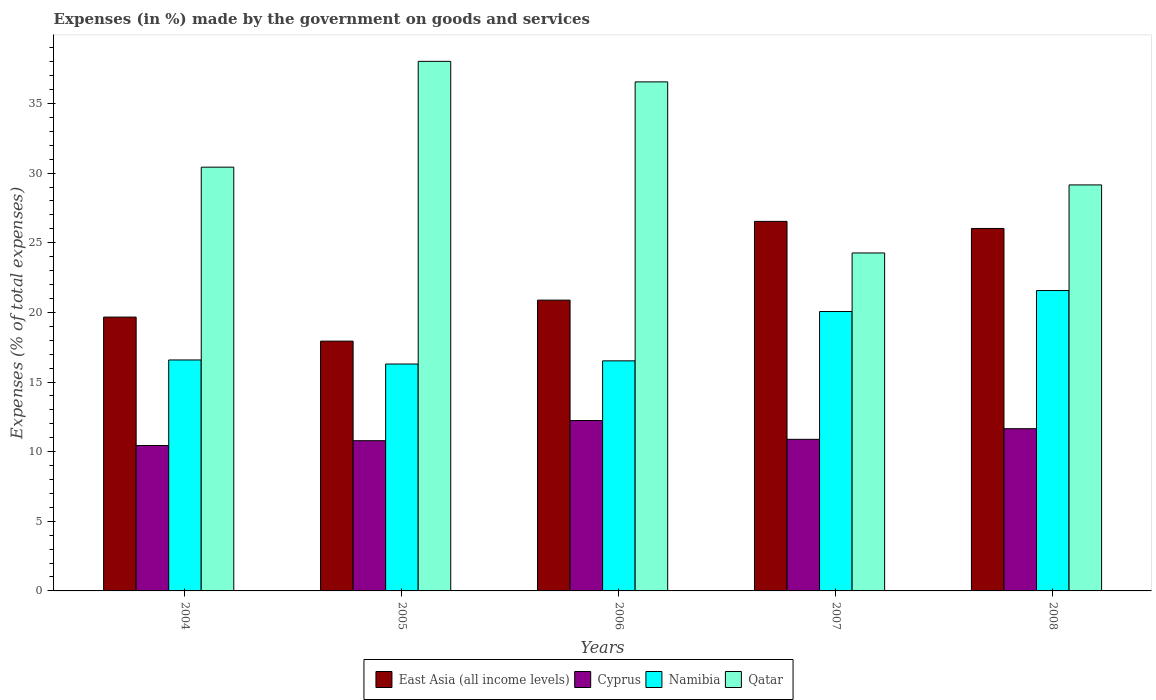Are the number of bars per tick equal to the number of legend labels?
Your answer should be compact. Yes. How many bars are there on the 2nd tick from the right?
Your answer should be very brief. 4. What is the label of the 5th group of bars from the left?
Keep it short and to the point. 2008. What is the percentage of expenses made by the government on goods and services in Qatar in 2007?
Make the answer very short. 24.27. Across all years, what is the maximum percentage of expenses made by the government on goods and services in East Asia (all income levels)?
Your answer should be compact. 26.53. Across all years, what is the minimum percentage of expenses made by the government on goods and services in Qatar?
Provide a short and direct response. 24.27. In which year was the percentage of expenses made by the government on goods and services in East Asia (all income levels) minimum?
Your answer should be compact. 2005. What is the total percentage of expenses made by the government on goods and services in Cyprus in the graph?
Ensure brevity in your answer.  56. What is the difference between the percentage of expenses made by the government on goods and services in Namibia in 2005 and that in 2006?
Provide a succinct answer. -0.23. What is the difference between the percentage of expenses made by the government on goods and services in Cyprus in 2007 and the percentage of expenses made by the government on goods and services in East Asia (all income levels) in 2004?
Make the answer very short. -8.78. What is the average percentage of expenses made by the government on goods and services in East Asia (all income levels) per year?
Provide a short and direct response. 22.21. In the year 2007, what is the difference between the percentage of expenses made by the government on goods and services in East Asia (all income levels) and percentage of expenses made by the government on goods and services in Qatar?
Make the answer very short. 2.27. In how many years, is the percentage of expenses made by the government on goods and services in Namibia greater than 13 %?
Your answer should be very brief. 5. What is the ratio of the percentage of expenses made by the government on goods and services in Qatar in 2005 to that in 2006?
Provide a succinct answer. 1.04. Is the percentage of expenses made by the government on goods and services in East Asia (all income levels) in 2004 less than that in 2006?
Provide a succinct answer. Yes. What is the difference between the highest and the second highest percentage of expenses made by the government on goods and services in Cyprus?
Your answer should be compact. 0.59. What is the difference between the highest and the lowest percentage of expenses made by the government on goods and services in Qatar?
Make the answer very short. 13.76. In how many years, is the percentage of expenses made by the government on goods and services in Qatar greater than the average percentage of expenses made by the government on goods and services in Qatar taken over all years?
Provide a short and direct response. 2. Is the sum of the percentage of expenses made by the government on goods and services in Namibia in 2004 and 2007 greater than the maximum percentage of expenses made by the government on goods and services in East Asia (all income levels) across all years?
Your response must be concise. Yes. Is it the case that in every year, the sum of the percentage of expenses made by the government on goods and services in East Asia (all income levels) and percentage of expenses made by the government on goods and services in Namibia is greater than the sum of percentage of expenses made by the government on goods and services in Cyprus and percentage of expenses made by the government on goods and services in Qatar?
Give a very brief answer. No. What does the 3rd bar from the left in 2004 represents?
Keep it short and to the point. Namibia. What does the 3rd bar from the right in 2006 represents?
Ensure brevity in your answer.  Cyprus. Is it the case that in every year, the sum of the percentage of expenses made by the government on goods and services in East Asia (all income levels) and percentage of expenses made by the government on goods and services in Cyprus is greater than the percentage of expenses made by the government on goods and services in Namibia?
Your response must be concise. Yes. How many bars are there?
Offer a terse response. 20. Are all the bars in the graph horizontal?
Your answer should be compact. No. What is the difference between two consecutive major ticks on the Y-axis?
Make the answer very short. 5. Where does the legend appear in the graph?
Give a very brief answer. Bottom center. How are the legend labels stacked?
Your answer should be compact. Horizontal. What is the title of the graph?
Provide a succinct answer. Expenses (in %) made by the government on goods and services. Does "Philippines" appear as one of the legend labels in the graph?
Ensure brevity in your answer.  No. What is the label or title of the Y-axis?
Provide a short and direct response. Expenses (% of total expenses). What is the Expenses (% of total expenses) of East Asia (all income levels) in 2004?
Provide a succinct answer. 19.66. What is the Expenses (% of total expenses) of Cyprus in 2004?
Keep it short and to the point. 10.44. What is the Expenses (% of total expenses) in Namibia in 2004?
Ensure brevity in your answer.  16.58. What is the Expenses (% of total expenses) of Qatar in 2004?
Offer a very short reply. 30.43. What is the Expenses (% of total expenses) of East Asia (all income levels) in 2005?
Offer a very short reply. 17.94. What is the Expenses (% of total expenses) of Cyprus in 2005?
Your answer should be compact. 10.79. What is the Expenses (% of total expenses) in Namibia in 2005?
Your response must be concise. 16.29. What is the Expenses (% of total expenses) in Qatar in 2005?
Offer a terse response. 38.02. What is the Expenses (% of total expenses) of East Asia (all income levels) in 2006?
Your answer should be very brief. 20.88. What is the Expenses (% of total expenses) of Cyprus in 2006?
Make the answer very short. 12.24. What is the Expenses (% of total expenses) in Namibia in 2006?
Give a very brief answer. 16.52. What is the Expenses (% of total expenses) in Qatar in 2006?
Provide a succinct answer. 36.55. What is the Expenses (% of total expenses) of East Asia (all income levels) in 2007?
Provide a short and direct response. 26.53. What is the Expenses (% of total expenses) in Cyprus in 2007?
Give a very brief answer. 10.89. What is the Expenses (% of total expenses) of Namibia in 2007?
Your answer should be very brief. 20.06. What is the Expenses (% of total expenses) in Qatar in 2007?
Your answer should be very brief. 24.27. What is the Expenses (% of total expenses) in East Asia (all income levels) in 2008?
Your response must be concise. 26.02. What is the Expenses (% of total expenses) in Cyprus in 2008?
Give a very brief answer. 11.65. What is the Expenses (% of total expenses) of Namibia in 2008?
Offer a terse response. 21.57. What is the Expenses (% of total expenses) in Qatar in 2008?
Ensure brevity in your answer.  29.15. Across all years, what is the maximum Expenses (% of total expenses) of East Asia (all income levels)?
Ensure brevity in your answer.  26.53. Across all years, what is the maximum Expenses (% of total expenses) of Cyprus?
Provide a short and direct response. 12.24. Across all years, what is the maximum Expenses (% of total expenses) of Namibia?
Your response must be concise. 21.57. Across all years, what is the maximum Expenses (% of total expenses) in Qatar?
Your answer should be compact. 38.02. Across all years, what is the minimum Expenses (% of total expenses) of East Asia (all income levels)?
Provide a succinct answer. 17.94. Across all years, what is the minimum Expenses (% of total expenses) in Cyprus?
Provide a succinct answer. 10.44. Across all years, what is the minimum Expenses (% of total expenses) in Namibia?
Give a very brief answer. 16.29. Across all years, what is the minimum Expenses (% of total expenses) of Qatar?
Offer a terse response. 24.27. What is the total Expenses (% of total expenses) of East Asia (all income levels) in the graph?
Your answer should be compact. 111.03. What is the total Expenses (% of total expenses) in Cyprus in the graph?
Offer a very short reply. 56. What is the total Expenses (% of total expenses) of Namibia in the graph?
Offer a terse response. 91.02. What is the total Expenses (% of total expenses) of Qatar in the graph?
Provide a succinct answer. 158.42. What is the difference between the Expenses (% of total expenses) in East Asia (all income levels) in 2004 and that in 2005?
Your answer should be compact. 1.73. What is the difference between the Expenses (% of total expenses) of Cyprus in 2004 and that in 2005?
Keep it short and to the point. -0.35. What is the difference between the Expenses (% of total expenses) in Namibia in 2004 and that in 2005?
Keep it short and to the point. 0.29. What is the difference between the Expenses (% of total expenses) in Qatar in 2004 and that in 2005?
Give a very brief answer. -7.6. What is the difference between the Expenses (% of total expenses) in East Asia (all income levels) in 2004 and that in 2006?
Make the answer very short. -1.22. What is the difference between the Expenses (% of total expenses) of Cyprus in 2004 and that in 2006?
Keep it short and to the point. -1.8. What is the difference between the Expenses (% of total expenses) of Namibia in 2004 and that in 2006?
Provide a succinct answer. 0.06. What is the difference between the Expenses (% of total expenses) of Qatar in 2004 and that in 2006?
Your response must be concise. -6.12. What is the difference between the Expenses (% of total expenses) of East Asia (all income levels) in 2004 and that in 2007?
Provide a succinct answer. -6.87. What is the difference between the Expenses (% of total expenses) of Cyprus in 2004 and that in 2007?
Your answer should be very brief. -0.45. What is the difference between the Expenses (% of total expenses) of Namibia in 2004 and that in 2007?
Ensure brevity in your answer.  -3.48. What is the difference between the Expenses (% of total expenses) in Qatar in 2004 and that in 2007?
Give a very brief answer. 6.16. What is the difference between the Expenses (% of total expenses) of East Asia (all income levels) in 2004 and that in 2008?
Provide a short and direct response. -6.36. What is the difference between the Expenses (% of total expenses) in Cyprus in 2004 and that in 2008?
Your answer should be very brief. -1.21. What is the difference between the Expenses (% of total expenses) of Namibia in 2004 and that in 2008?
Keep it short and to the point. -4.98. What is the difference between the Expenses (% of total expenses) in Qatar in 2004 and that in 2008?
Your response must be concise. 1.27. What is the difference between the Expenses (% of total expenses) of East Asia (all income levels) in 2005 and that in 2006?
Ensure brevity in your answer.  -2.94. What is the difference between the Expenses (% of total expenses) of Cyprus in 2005 and that in 2006?
Offer a terse response. -1.45. What is the difference between the Expenses (% of total expenses) in Namibia in 2005 and that in 2006?
Provide a short and direct response. -0.23. What is the difference between the Expenses (% of total expenses) of Qatar in 2005 and that in 2006?
Offer a terse response. 1.47. What is the difference between the Expenses (% of total expenses) in East Asia (all income levels) in 2005 and that in 2007?
Your response must be concise. -8.6. What is the difference between the Expenses (% of total expenses) in Cyprus in 2005 and that in 2007?
Your response must be concise. -0.1. What is the difference between the Expenses (% of total expenses) in Namibia in 2005 and that in 2007?
Keep it short and to the point. -3.77. What is the difference between the Expenses (% of total expenses) of Qatar in 2005 and that in 2007?
Provide a short and direct response. 13.76. What is the difference between the Expenses (% of total expenses) in East Asia (all income levels) in 2005 and that in 2008?
Your answer should be compact. -8.09. What is the difference between the Expenses (% of total expenses) of Cyprus in 2005 and that in 2008?
Offer a very short reply. -0.86. What is the difference between the Expenses (% of total expenses) in Namibia in 2005 and that in 2008?
Give a very brief answer. -5.28. What is the difference between the Expenses (% of total expenses) of Qatar in 2005 and that in 2008?
Offer a terse response. 8.87. What is the difference between the Expenses (% of total expenses) in East Asia (all income levels) in 2006 and that in 2007?
Your answer should be very brief. -5.65. What is the difference between the Expenses (% of total expenses) of Cyprus in 2006 and that in 2007?
Ensure brevity in your answer.  1.35. What is the difference between the Expenses (% of total expenses) in Namibia in 2006 and that in 2007?
Offer a very short reply. -3.54. What is the difference between the Expenses (% of total expenses) of Qatar in 2006 and that in 2007?
Ensure brevity in your answer.  12.28. What is the difference between the Expenses (% of total expenses) of East Asia (all income levels) in 2006 and that in 2008?
Offer a terse response. -5.15. What is the difference between the Expenses (% of total expenses) of Cyprus in 2006 and that in 2008?
Your answer should be very brief. 0.59. What is the difference between the Expenses (% of total expenses) in Namibia in 2006 and that in 2008?
Make the answer very short. -5.05. What is the difference between the Expenses (% of total expenses) of Qatar in 2006 and that in 2008?
Offer a terse response. 7.4. What is the difference between the Expenses (% of total expenses) of East Asia (all income levels) in 2007 and that in 2008?
Provide a short and direct response. 0.51. What is the difference between the Expenses (% of total expenses) in Cyprus in 2007 and that in 2008?
Make the answer very short. -0.76. What is the difference between the Expenses (% of total expenses) of Namibia in 2007 and that in 2008?
Offer a terse response. -1.51. What is the difference between the Expenses (% of total expenses) of Qatar in 2007 and that in 2008?
Provide a short and direct response. -4.89. What is the difference between the Expenses (% of total expenses) of East Asia (all income levels) in 2004 and the Expenses (% of total expenses) of Cyprus in 2005?
Give a very brief answer. 8.88. What is the difference between the Expenses (% of total expenses) in East Asia (all income levels) in 2004 and the Expenses (% of total expenses) in Namibia in 2005?
Give a very brief answer. 3.37. What is the difference between the Expenses (% of total expenses) in East Asia (all income levels) in 2004 and the Expenses (% of total expenses) in Qatar in 2005?
Your response must be concise. -18.36. What is the difference between the Expenses (% of total expenses) in Cyprus in 2004 and the Expenses (% of total expenses) in Namibia in 2005?
Your answer should be very brief. -5.85. What is the difference between the Expenses (% of total expenses) in Cyprus in 2004 and the Expenses (% of total expenses) in Qatar in 2005?
Offer a terse response. -27.58. What is the difference between the Expenses (% of total expenses) of Namibia in 2004 and the Expenses (% of total expenses) of Qatar in 2005?
Offer a terse response. -21.44. What is the difference between the Expenses (% of total expenses) of East Asia (all income levels) in 2004 and the Expenses (% of total expenses) of Cyprus in 2006?
Offer a terse response. 7.43. What is the difference between the Expenses (% of total expenses) in East Asia (all income levels) in 2004 and the Expenses (% of total expenses) in Namibia in 2006?
Provide a short and direct response. 3.14. What is the difference between the Expenses (% of total expenses) of East Asia (all income levels) in 2004 and the Expenses (% of total expenses) of Qatar in 2006?
Provide a succinct answer. -16.89. What is the difference between the Expenses (% of total expenses) in Cyprus in 2004 and the Expenses (% of total expenses) in Namibia in 2006?
Your answer should be compact. -6.08. What is the difference between the Expenses (% of total expenses) in Cyprus in 2004 and the Expenses (% of total expenses) in Qatar in 2006?
Give a very brief answer. -26.11. What is the difference between the Expenses (% of total expenses) in Namibia in 2004 and the Expenses (% of total expenses) in Qatar in 2006?
Your response must be concise. -19.97. What is the difference between the Expenses (% of total expenses) of East Asia (all income levels) in 2004 and the Expenses (% of total expenses) of Cyprus in 2007?
Make the answer very short. 8.78. What is the difference between the Expenses (% of total expenses) of East Asia (all income levels) in 2004 and the Expenses (% of total expenses) of Namibia in 2007?
Your response must be concise. -0.4. What is the difference between the Expenses (% of total expenses) of East Asia (all income levels) in 2004 and the Expenses (% of total expenses) of Qatar in 2007?
Your answer should be compact. -4.6. What is the difference between the Expenses (% of total expenses) in Cyprus in 2004 and the Expenses (% of total expenses) in Namibia in 2007?
Provide a succinct answer. -9.62. What is the difference between the Expenses (% of total expenses) of Cyprus in 2004 and the Expenses (% of total expenses) of Qatar in 2007?
Ensure brevity in your answer.  -13.83. What is the difference between the Expenses (% of total expenses) of Namibia in 2004 and the Expenses (% of total expenses) of Qatar in 2007?
Offer a very short reply. -7.68. What is the difference between the Expenses (% of total expenses) in East Asia (all income levels) in 2004 and the Expenses (% of total expenses) in Cyprus in 2008?
Offer a very short reply. 8.01. What is the difference between the Expenses (% of total expenses) of East Asia (all income levels) in 2004 and the Expenses (% of total expenses) of Namibia in 2008?
Offer a very short reply. -1.91. What is the difference between the Expenses (% of total expenses) of East Asia (all income levels) in 2004 and the Expenses (% of total expenses) of Qatar in 2008?
Keep it short and to the point. -9.49. What is the difference between the Expenses (% of total expenses) of Cyprus in 2004 and the Expenses (% of total expenses) of Namibia in 2008?
Your response must be concise. -11.13. What is the difference between the Expenses (% of total expenses) in Cyprus in 2004 and the Expenses (% of total expenses) in Qatar in 2008?
Keep it short and to the point. -18.71. What is the difference between the Expenses (% of total expenses) of Namibia in 2004 and the Expenses (% of total expenses) of Qatar in 2008?
Your answer should be very brief. -12.57. What is the difference between the Expenses (% of total expenses) of East Asia (all income levels) in 2005 and the Expenses (% of total expenses) of Cyprus in 2006?
Give a very brief answer. 5.7. What is the difference between the Expenses (% of total expenses) in East Asia (all income levels) in 2005 and the Expenses (% of total expenses) in Namibia in 2006?
Your answer should be very brief. 1.42. What is the difference between the Expenses (% of total expenses) of East Asia (all income levels) in 2005 and the Expenses (% of total expenses) of Qatar in 2006?
Offer a terse response. -18.61. What is the difference between the Expenses (% of total expenses) in Cyprus in 2005 and the Expenses (% of total expenses) in Namibia in 2006?
Ensure brevity in your answer.  -5.73. What is the difference between the Expenses (% of total expenses) in Cyprus in 2005 and the Expenses (% of total expenses) in Qatar in 2006?
Provide a short and direct response. -25.76. What is the difference between the Expenses (% of total expenses) of Namibia in 2005 and the Expenses (% of total expenses) of Qatar in 2006?
Provide a succinct answer. -20.26. What is the difference between the Expenses (% of total expenses) of East Asia (all income levels) in 2005 and the Expenses (% of total expenses) of Cyprus in 2007?
Offer a very short reply. 7.05. What is the difference between the Expenses (% of total expenses) in East Asia (all income levels) in 2005 and the Expenses (% of total expenses) in Namibia in 2007?
Offer a very short reply. -2.13. What is the difference between the Expenses (% of total expenses) in East Asia (all income levels) in 2005 and the Expenses (% of total expenses) in Qatar in 2007?
Provide a succinct answer. -6.33. What is the difference between the Expenses (% of total expenses) of Cyprus in 2005 and the Expenses (% of total expenses) of Namibia in 2007?
Your answer should be compact. -9.27. What is the difference between the Expenses (% of total expenses) in Cyprus in 2005 and the Expenses (% of total expenses) in Qatar in 2007?
Keep it short and to the point. -13.48. What is the difference between the Expenses (% of total expenses) in Namibia in 2005 and the Expenses (% of total expenses) in Qatar in 2007?
Your answer should be compact. -7.97. What is the difference between the Expenses (% of total expenses) of East Asia (all income levels) in 2005 and the Expenses (% of total expenses) of Cyprus in 2008?
Your answer should be compact. 6.29. What is the difference between the Expenses (% of total expenses) of East Asia (all income levels) in 2005 and the Expenses (% of total expenses) of Namibia in 2008?
Provide a succinct answer. -3.63. What is the difference between the Expenses (% of total expenses) of East Asia (all income levels) in 2005 and the Expenses (% of total expenses) of Qatar in 2008?
Your response must be concise. -11.22. What is the difference between the Expenses (% of total expenses) in Cyprus in 2005 and the Expenses (% of total expenses) in Namibia in 2008?
Provide a short and direct response. -10.78. What is the difference between the Expenses (% of total expenses) in Cyprus in 2005 and the Expenses (% of total expenses) in Qatar in 2008?
Offer a terse response. -18.37. What is the difference between the Expenses (% of total expenses) in Namibia in 2005 and the Expenses (% of total expenses) in Qatar in 2008?
Offer a very short reply. -12.86. What is the difference between the Expenses (% of total expenses) of East Asia (all income levels) in 2006 and the Expenses (% of total expenses) of Cyprus in 2007?
Offer a terse response. 9.99. What is the difference between the Expenses (% of total expenses) in East Asia (all income levels) in 2006 and the Expenses (% of total expenses) in Namibia in 2007?
Your answer should be very brief. 0.82. What is the difference between the Expenses (% of total expenses) in East Asia (all income levels) in 2006 and the Expenses (% of total expenses) in Qatar in 2007?
Provide a succinct answer. -3.39. What is the difference between the Expenses (% of total expenses) of Cyprus in 2006 and the Expenses (% of total expenses) of Namibia in 2007?
Keep it short and to the point. -7.82. What is the difference between the Expenses (% of total expenses) of Cyprus in 2006 and the Expenses (% of total expenses) of Qatar in 2007?
Provide a short and direct response. -12.03. What is the difference between the Expenses (% of total expenses) in Namibia in 2006 and the Expenses (% of total expenses) in Qatar in 2007?
Keep it short and to the point. -7.75. What is the difference between the Expenses (% of total expenses) in East Asia (all income levels) in 2006 and the Expenses (% of total expenses) in Cyprus in 2008?
Provide a short and direct response. 9.23. What is the difference between the Expenses (% of total expenses) in East Asia (all income levels) in 2006 and the Expenses (% of total expenses) in Namibia in 2008?
Your answer should be very brief. -0.69. What is the difference between the Expenses (% of total expenses) of East Asia (all income levels) in 2006 and the Expenses (% of total expenses) of Qatar in 2008?
Give a very brief answer. -8.27. What is the difference between the Expenses (% of total expenses) of Cyprus in 2006 and the Expenses (% of total expenses) of Namibia in 2008?
Make the answer very short. -9.33. What is the difference between the Expenses (% of total expenses) of Cyprus in 2006 and the Expenses (% of total expenses) of Qatar in 2008?
Provide a succinct answer. -16.92. What is the difference between the Expenses (% of total expenses) in Namibia in 2006 and the Expenses (% of total expenses) in Qatar in 2008?
Ensure brevity in your answer.  -12.63. What is the difference between the Expenses (% of total expenses) of East Asia (all income levels) in 2007 and the Expenses (% of total expenses) of Cyprus in 2008?
Make the answer very short. 14.89. What is the difference between the Expenses (% of total expenses) in East Asia (all income levels) in 2007 and the Expenses (% of total expenses) in Namibia in 2008?
Your answer should be compact. 4.97. What is the difference between the Expenses (% of total expenses) in East Asia (all income levels) in 2007 and the Expenses (% of total expenses) in Qatar in 2008?
Your answer should be compact. -2.62. What is the difference between the Expenses (% of total expenses) of Cyprus in 2007 and the Expenses (% of total expenses) of Namibia in 2008?
Give a very brief answer. -10.68. What is the difference between the Expenses (% of total expenses) of Cyprus in 2007 and the Expenses (% of total expenses) of Qatar in 2008?
Give a very brief answer. -18.27. What is the difference between the Expenses (% of total expenses) of Namibia in 2007 and the Expenses (% of total expenses) of Qatar in 2008?
Give a very brief answer. -9.09. What is the average Expenses (% of total expenses) of East Asia (all income levels) per year?
Offer a very short reply. 22.21. What is the average Expenses (% of total expenses) in Cyprus per year?
Ensure brevity in your answer.  11.2. What is the average Expenses (% of total expenses) of Namibia per year?
Offer a very short reply. 18.2. What is the average Expenses (% of total expenses) in Qatar per year?
Offer a terse response. 31.68. In the year 2004, what is the difference between the Expenses (% of total expenses) of East Asia (all income levels) and Expenses (% of total expenses) of Cyprus?
Offer a terse response. 9.22. In the year 2004, what is the difference between the Expenses (% of total expenses) of East Asia (all income levels) and Expenses (% of total expenses) of Namibia?
Make the answer very short. 3.08. In the year 2004, what is the difference between the Expenses (% of total expenses) in East Asia (all income levels) and Expenses (% of total expenses) in Qatar?
Ensure brevity in your answer.  -10.76. In the year 2004, what is the difference between the Expenses (% of total expenses) of Cyprus and Expenses (% of total expenses) of Namibia?
Offer a very short reply. -6.14. In the year 2004, what is the difference between the Expenses (% of total expenses) of Cyprus and Expenses (% of total expenses) of Qatar?
Provide a short and direct response. -19.99. In the year 2004, what is the difference between the Expenses (% of total expenses) of Namibia and Expenses (% of total expenses) of Qatar?
Keep it short and to the point. -13.84. In the year 2005, what is the difference between the Expenses (% of total expenses) of East Asia (all income levels) and Expenses (% of total expenses) of Cyprus?
Give a very brief answer. 7.15. In the year 2005, what is the difference between the Expenses (% of total expenses) of East Asia (all income levels) and Expenses (% of total expenses) of Namibia?
Offer a very short reply. 1.64. In the year 2005, what is the difference between the Expenses (% of total expenses) in East Asia (all income levels) and Expenses (% of total expenses) in Qatar?
Your answer should be compact. -20.09. In the year 2005, what is the difference between the Expenses (% of total expenses) of Cyprus and Expenses (% of total expenses) of Namibia?
Provide a succinct answer. -5.51. In the year 2005, what is the difference between the Expenses (% of total expenses) in Cyprus and Expenses (% of total expenses) in Qatar?
Keep it short and to the point. -27.24. In the year 2005, what is the difference between the Expenses (% of total expenses) in Namibia and Expenses (% of total expenses) in Qatar?
Your response must be concise. -21.73. In the year 2006, what is the difference between the Expenses (% of total expenses) of East Asia (all income levels) and Expenses (% of total expenses) of Cyprus?
Your response must be concise. 8.64. In the year 2006, what is the difference between the Expenses (% of total expenses) in East Asia (all income levels) and Expenses (% of total expenses) in Namibia?
Make the answer very short. 4.36. In the year 2006, what is the difference between the Expenses (% of total expenses) in East Asia (all income levels) and Expenses (% of total expenses) in Qatar?
Your answer should be compact. -15.67. In the year 2006, what is the difference between the Expenses (% of total expenses) in Cyprus and Expenses (% of total expenses) in Namibia?
Provide a succinct answer. -4.28. In the year 2006, what is the difference between the Expenses (% of total expenses) in Cyprus and Expenses (% of total expenses) in Qatar?
Provide a short and direct response. -24.31. In the year 2006, what is the difference between the Expenses (% of total expenses) in Namibia and Expenses (% of total expenses) in Qatar?
Offer a terse response. -20.03. In the year 2007, what is the difference between the Expenses (% of total expenses) in East Asia (all income levels) and Expenses (% of total expenses) in Cyprus?
Provide a short and direct response. 15.65. In the year 2007, what is the difference between the Expenses (% of total expenses) of East Asia (all income levels) and Expenses (% of total expenses) of Namibia?
Your response must be concise. 6.47. In the year 2007, what is the difference between the Expenses (% of total expenses) of East Asia (all income levels) and Expenses (% of total expenses) of Qatar?
Make the answer very short. 2.27. In the year 2007, what is the difference between the Expenses (% of total expenses) in Cyprus and Expenses (% of total expenses) in Namibia?
Your answer should be very brief. -9.18. In the year 2007, what is the difference between the Expenses (% of total expenses) in Cyprus and Expenses (% of total expenses) in Qatar?
Your response must be concise. -13.38. In the year 2007, what is the difference between the Expenses (% of total expenses) of Namibia and Expenses (% of total expenses) of Qatar?
Your response must be concise. -4.21. In the year 2008, what is the difference between the Expenses (% of total expenses) of East Asia (all income levels) and Expenses (% of total expenses) of Cyprus?
Provide a succinct answer. 14.38. In the year 2008, what is the difference between the Expenses (% of total expenses) in East Asia (all income levels) and Expenses (% of total expenses) in Namibia?
Your answer should be very brief. 4.46. In the year 2008, what is the difference between the Expenses (% of total expenses) in East Asia (all income levels) and Expenses (% of total expenses) in Qatar?
Give a very brief answer. -3.13. In the year 2008, what is the difference between the Expenses (% of total expenses) of Cyprus and Expenses (% of total expenses) of Namibia?
Your answer should be very brief. -9.92. In the year 2008, what is the difference between the Expenses (% of total expenses) in Cyprus and Expenses (% of total expenses) in Qatar?
Your response must be concise. -17.5. In the year 2008, what is the difference between the Expenses (% of total expenses) of Namibia and Expenses (% of total expenses) of Qatar?
Offer a terse response. -7.58. What is the ratio of the Expenses (% of total expenses) of East Asia (all income levels) in 2004 to that in 2005?
Your answer should be compact. 1.1. What is the ratio of the Expenses (% of total expenses) of Cyprus in 2004 to that in 2005?
Your answer should be very brief. 0.97. What is the ratio of the Expenses (% of total expenses) of Namibia in 2004 to that in 2005?
Your answer should be compact. 1.02. What is the ratio of the Expenses (% of total expenses) in Qatar in 2004 to that in 2005?
Give a very brief answer. 0.8. What is the ratio of the Expenses (% of total expenses) of East Asia (all income levels) in 2004 to that in 2006?
Make the answer very short. 0.94. What is the ratio of the Expenses (% of total expenses) of Cyprus in 2004 to that in 2006?
Provide a short and direct response. 0.85. What is the ratio of the Expenses (% of total expenses) of Qatar in 2004 to that in 2006?
Provide a succinct answer. 0.83. What is the ratio of the Expenses (% of total expenses) of East Asia (all income levels) in 2004 to that in 2007?
Offer a very short reply. 0.74. What is the ratio of the Expenses (% of total expenses) in Cyprus in 2004 to that in 2007?
Provide a succinct answer. 0.96. What is the ratio of the Expenses (% of total expenses) of Namibia in 2004 to that in 2007?
Keep it short and to the point. 0.83. What is the ratio of the Expenses (% of total expenses) of Qatar in 2004 to that in 2007?
Offer a terse response. 1.25. What is the ratio of the Expenses (% of total expenses) in East Asia (all income levels) in 2004 to that in 2008?
Your response must be concise. 0.76. What is the ratio of the Expenses (% of total expenses) of Cyprus in 2004 to that in 2008?
Ensure brevity in your answer.  0.9. What is the ratio of the Expenses (% of total expenses) in Namibia in 2004 to that in 2008?
Keep it short and to the point. 0.77. What is the ratio of the Expenses (% of total expenses) of Qatar in 2004 to that in 2008?
Provide a succinct answer. 1.04. What is the ratio of the Expenses (% of total expenses) in East Asia (all income levels) in 2005 to that in 2006?
Give a very brief answer. 0.86. What is the ratio of the Expenses (% of total expenses) of Cyprus in 2005 to that in 2006?
Your answer should be very brief. 0.88. What is the ratio of the Expenses (% of total expenses) in Namibia in 2005 to that in 2006?
Your response must be concise. 0.99. What is the ratio of the Expenses (% of total expenses) of Qatar in 2005 to that in 2006?
Give a very brief answer. 1.04. What is the ratio of the Expenses (% of total expenses) of East Asia (all income levels) in 2005 to that in 2007?
Keep it short and to the point. 0.68. What is the ratio of the Expenses (% of total expenses) in Cyprus in 2005 to that in 2007?
Provide a succinct answer. 0.99. What is the ratio of the Expenses (% of total expenses) of Namibia in 2005 to that in 2007?
Make the answer very short. 0.81. What is the ratio of the Expenses (% of total expenses) of Qatar in 2005 to that in 2007?
Provide a short and direct response. 1.57. What is the ratio of the Expenses (% of total expenses) in East Asia (all income levels) in 2005 to that in 2008?
Offer a terse response. 0.69. What is the ratio of the Expenses (% of total expenses) in Cyprus in 2005 to that in 2008?
Your answer should be very brief. 0.93. What is the ratio of the Expenses (% of total expenses) in Namibia in 2005 to that in 2008?
Your response must be concise. 0.76. What is the ratio of the Expenses (% of total expenses) of Qatar in 2005 to that in 2008?
Your answer should be very brief. 1.3. What is the ratio of the Expenses (% of total expenses) in East Asia (all income levels) in 2006 to that in 2007?
Ensure brevity in your answer.  0.79. What is the ratio of the Expenses (% of total expenses) of Cyprus in 2006 to that in 2007?
Provide a succinct answer. 1.12. What is the ratio of the Expenses (% of total expenses) of Namibia in 2006 to that in 2007?
Your answer should be very brief. 0.82. What is the ratio of the Expenses (% of total expenses) of Qatar in 2006 to that in 2007?
Ensure brevity in your answer.  1.51. What is the ratio of the Expenses (% of total expenses) of East Asia (all income levels) in 2006 to that in 2008?
Keep it short and to the point. 0.8. What is the ratio of the Expenses (% of total expenses) in Cyprus in 2006 to that in 2008?
Provide a succinct answer. 1.05. What is the ratio of the Expenses (% of total expenses) in Namibia in 2006 to that in 2008?
Your response must be concise. 0.77. What is the ratio of the Expenses (% of total expenses) of Qatar in 2006 to that in 2008?
Offer a terse response. 1.25. What is the ratio of the Expenses (% of total expenses) in East Asia (all income levels) in 2007 to that in 2008?
Provide a short and direct response. 1.02. What is the ratio of the Expenses (% of total expenses) of Cyprus in 2007 to that in 2008?
Your answer should be very brief. 0.93. What is the ratio of the Expenses (% of total expenses) of Namibia in 2007 to that in 2008?
Your answer should be very brief. 0.93. What is the ratio of the Expenses (% of total expenses) of Qatar in 2007 to that in 2008?
Your answer should be compact. 0.83. What is the difference between the highest and the second highest Expenses (% of total expenses) of East Asia (all income levels)?
Offer a terse response. 0.51. What is the difference between the highest and the second highest Expenses (% of total expenses) in Cyprus?
Your answer should be very brief. 0.59. What is the difference between the highest and the second highest Expenses (% of total expenses) of Namibia?
Your answer should be very brief. 1.51. What is the difference between the highest and the second highest Expenses (% of total expenses) of Qatar?
Provide a short and direct response. 1.47. What is the difference between the highest and the lowest Expenses (% of total expenses) in East Asia (all income levels)?
Provide a short and direct response. 8.6. What is the difference between the highest and the lowest Expenses (% of total expenses) in Cyprus?
Give a very brief answer. 1.8. What is the difference between the highest and the lowest Expenses (% of total expenses) in Namibia?
Offer a very short reply. 5.28. What is the difference between the highest and the lowest Expenses (% of total expenses) in Qatar?
Make the answer very short. 13.76. 